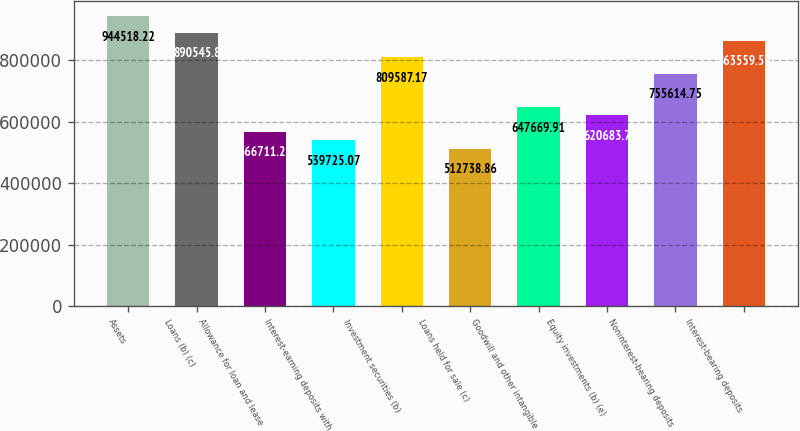<chart> <loc_0><loc_0><loc_500><loc_500><bar_chart><fcel>Assets<fcel>Loans (b) (c)<fcel>Allowance for loan and lease<fcel>Interest-earning deposits with<fcel>Investment securities (b)<fcel>Loans held for sale (c)<fcel>Goodwill and other intangible<fcel>Equity investments (b) (e)<fcel>Noninterest-bearing deposits<fcel>Interest-bearing deposits<nl><fcel>944518<fcel>890546<fcel>566711<fcel>539725<fcel>809587<fcel>512739<fcel>647670<fcel>620684<fcel>755615<fcel>863560<nl></chart> 